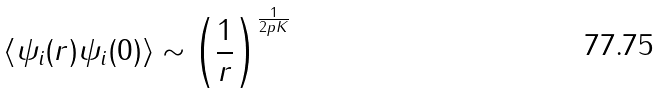Convert formula to latex. <formula><loc_0><loc_0><loc_500><loc_500>\langle \psi _ { i } ( r ) \psi _ { i } ( 0 ) \rangle \sim \left ( \frac { 1 } { r } \right ) ^ { \frac { 1 } { 2 p K } }</formula> 